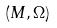Convert formula to latex. <formula><loc_0><loc_0><loc_500><loc_500>( M , \Omega )</formula> 